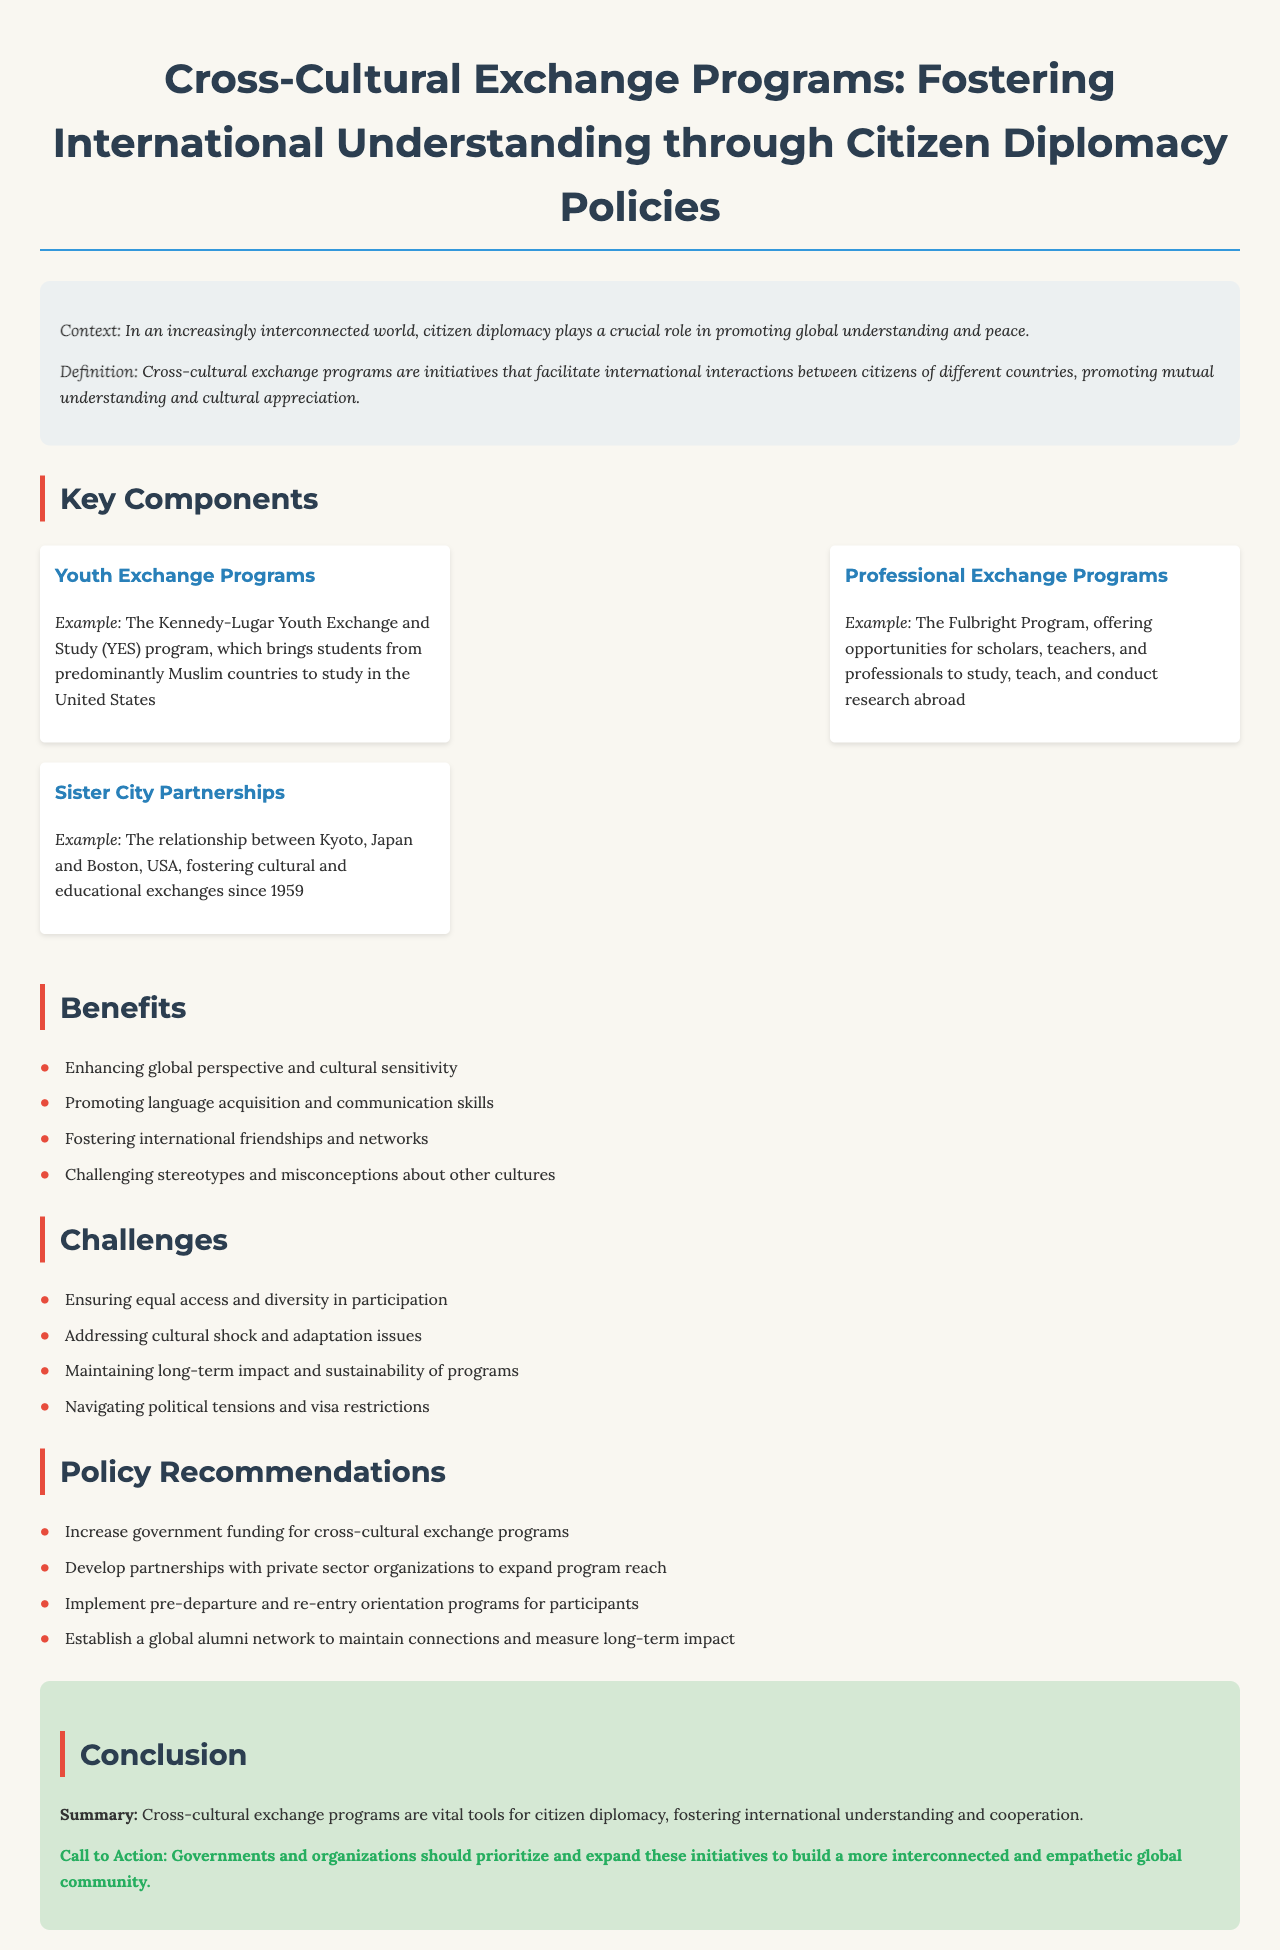What is the main context of the document? The main context discusses the role of citizen diplomacy in promoting global understanding and peace.
Answer: Global understanding and peace What is the definition of cross-cultural exchange programs? The document defines cross-cultural exchange programs as initiatives that facilitate international interactions between citizens of different countries.
Answer: Initiatives that facilitate international interactions What is an example of a youth exchange program mentioned? The document provides an example of the Kennedy-Lugar Youth Exchange and Study (YES) program bringing students from predominantly Muslim countries.
Answer: Kennedy-Lugar Youth Exchange and Study What percentage of the listed challenges relate to participation diversity? The document states that ensuring equal access and diversity in participation is one of the challenges outlined.
Answer: 25% What is one recommended policy to enhance cross-cultural exchange programs? The document recommends increasing government funding for cross-cultural exchange programs as a key policy action.
Answer: Increase government funding What year did the Kyoto-Boston sister city partnership begin? The document notes that the Kyoto and Boston sister city partnership has been fostering exchanges since 1959.
Answer: 1959 What is one benefit of cross-cultural exchange programs mentioned? One benefit highlighted is that cross-cultural exchange programs enhance global perspective and cultural sensitivity.
Answer: Enhancing global perspective What type of network is suggested to be established in the policy recommendations? The document suggests establishing a global alumni network to maintain connections and measure impact.
Answer: Global alumni network What does the conclusion emphasize about cross-cultural exchange programs? The conclusion emphasizes that cross-cultural exchange programs are vital tools for citizen diplomacy, fostering international understanding.
Answer: Vital tools for citizen diplomacy 